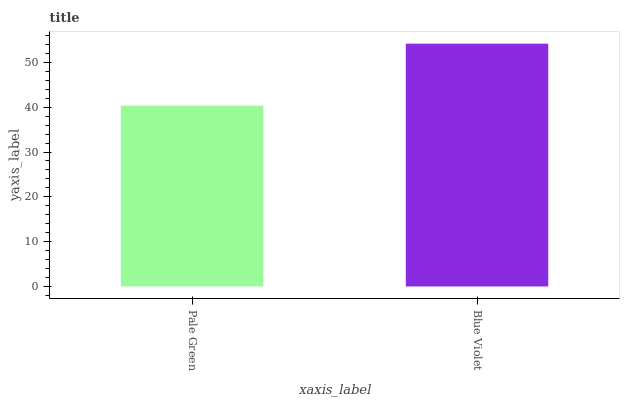Is Pale Green the minimum?
Answer yes or no. Yes. Is Blue Violet the maximum?
Answer yes or no. Yes. Is Blue Violet the minimum?
Answer yes or no. No. Is Blue Violet greater than Pale Green?
Answer yes or no. Yes. Is Pale Green less than Blue Violet?
Answer yes or no. Yes. Is Pale Green greater than Blue Violet?
Answer yes or no. No. Is Blue Violet less than Pale Green?
Answer yes or no. No. Is Blue Violet the high median?
Answer yes or no. Yes. Is Pale Green the low median?
Answer yes or no. Yes. Is Pale Green the high median?
Answer yes or no. No. Is Blue Violet the low median?
Answer yes or no. No. 